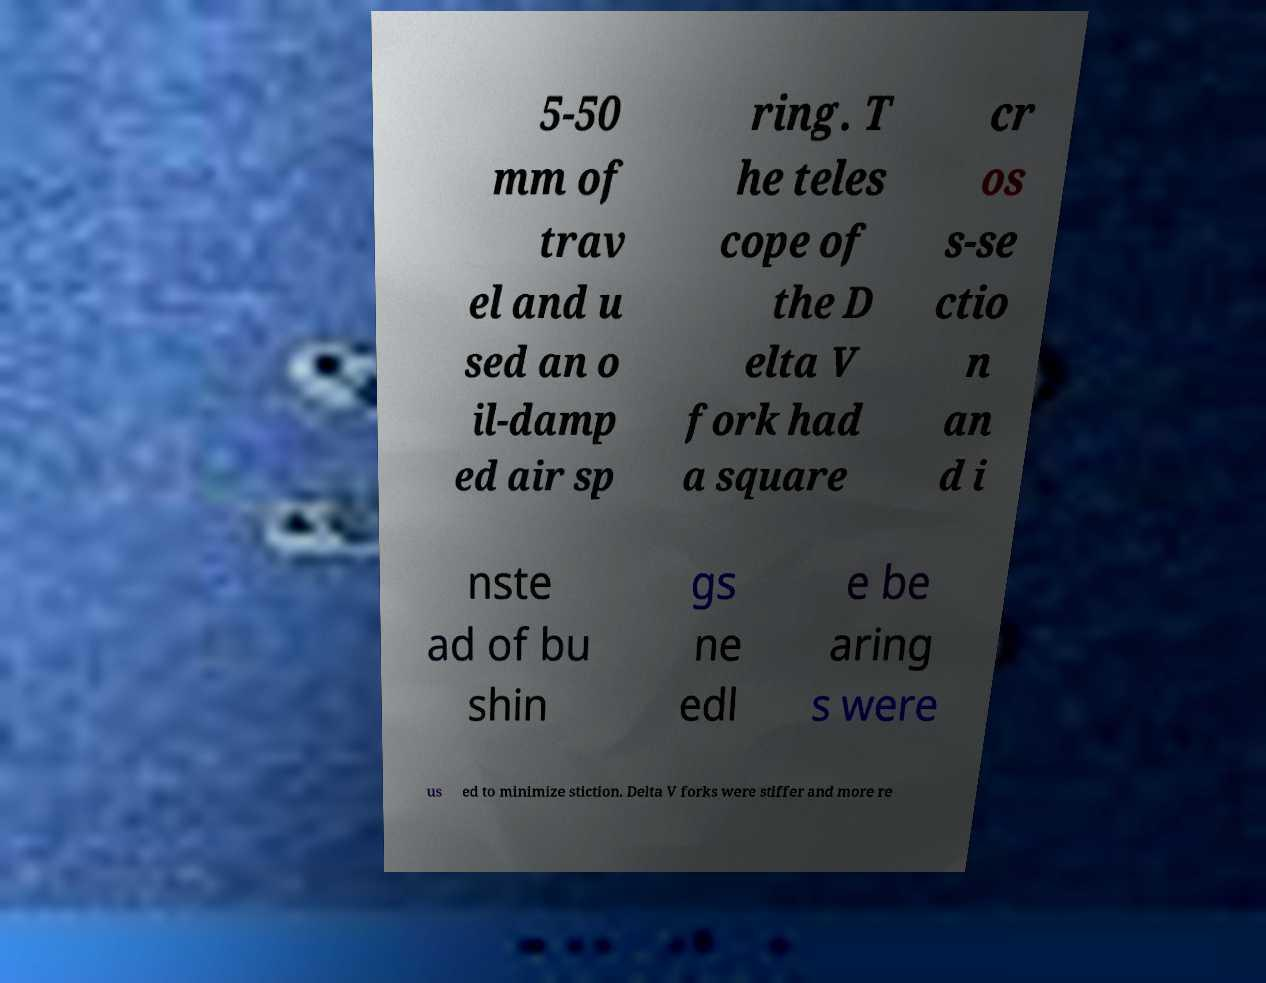I need the written content from this picture converted into text. Can you do that? 5-50 mm of trav el and u sed an o il-damp ed air sp ring. T he teles cope of the D elta V fork had a square cr os s-se ctio n an d i nste ad of bu shin gs ne edl e be aring s were us ed to minimize stiction. Delta V forks were stiffer and more re 